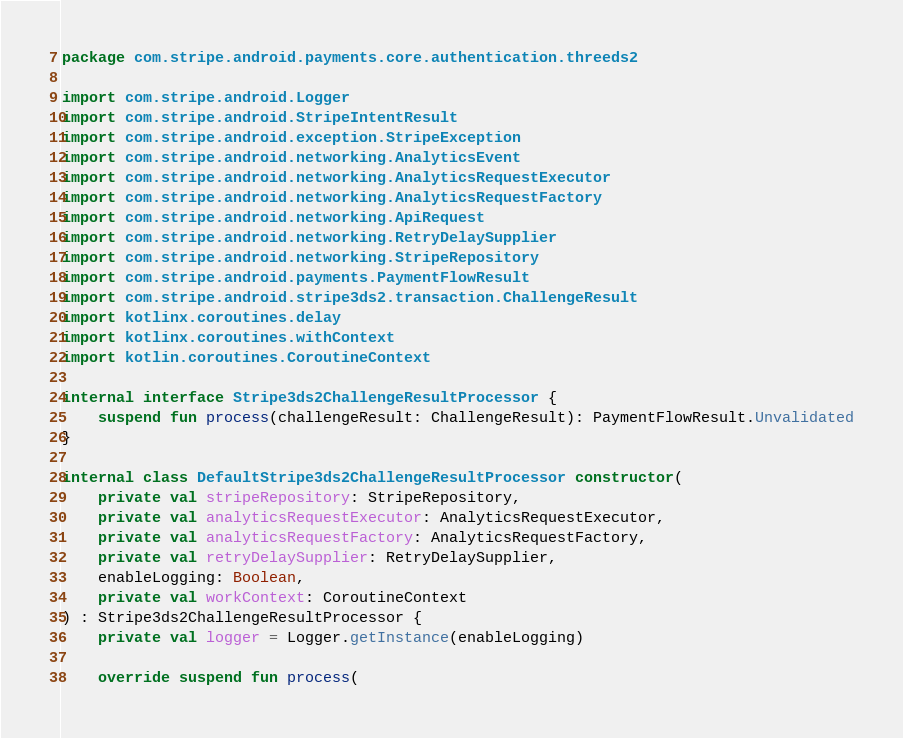Convert code to text. <code><loc_0><loc_0><loc_500><loc_500><_Kotlin_>package com.stripe.android.payments.core.authentication.threeds2

import com.stripe.android.Logger
import com.stripe.android.StripeIntentResult
import com.stripe.android.exception.StripeException
import com.stripe.android.networking.AnalyticsEvent
import com.stripe.android.networking.AnalyticsRequestExecutor
import com.stripe.android.networking.AnalyticsRequestFactory
import com.stripe.android.networking.ApiRequest
import com.stripe.android.networking.RetryDelaySupplier
import com.stripe.android.networking.StripeRepository
import com.stripe.android.payments.PaymentFlowResult
import com.stripe.android.stripe3ds2.transaction.ChallengeResult
import kotlinx.coroutines.delay
import kotlinx.coroutines.withContext
import kotlin.coroutines.CoroutineContext

internal interface Stripe3ds2ChallengeResultProcessor {
    suspend fun process(challengeResult: ChallengeResult): PaymentFlowResult.Unvalidated
}

internal class DefaultStripe3ds2ChallengeResultProcessor constructor(
    private val stripeRepository: StripeRepository,
    private val analyticsRequestExecutor: AnalyticsRequestExecutor,
    private val analyticsRequestFactory: AnalyticsRequestFactory,
    private val retryDelaySupplier: RetryDelaySupplier,
    enableLogging: Boolean,
    private val workContext: CoroutineContext
) : Stripe3ds2ChallengeResultProcessor {
    private val logger = Logger.getInstance(enableLogging)

    override suspend fun process(</code> 